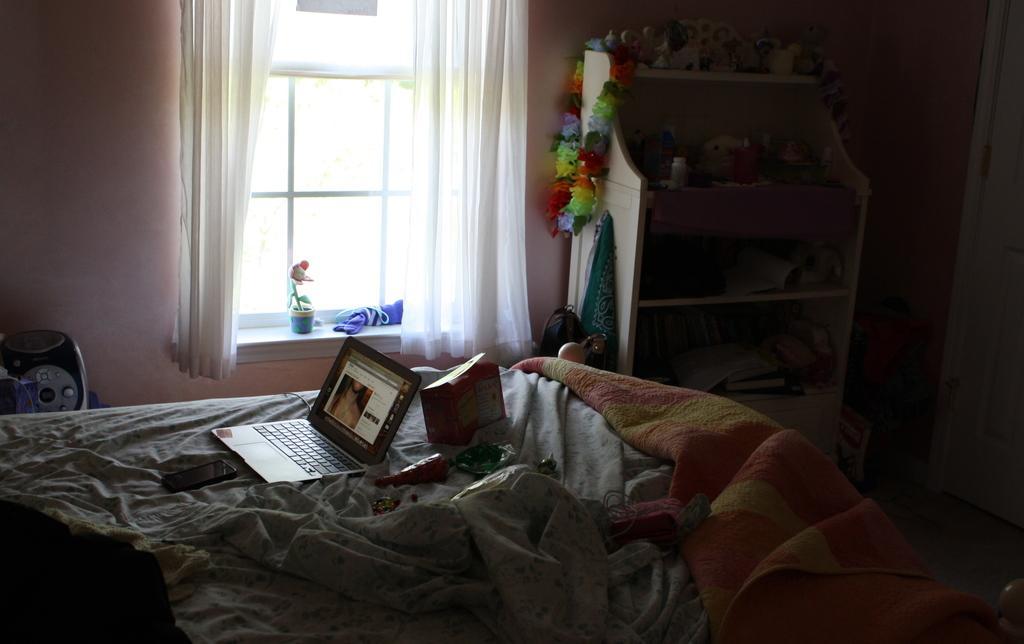In one or two sentences, can you explain what this image depicts? In this image there is an object and wall in the left corner. There is a bed, laptop, phone, blanket and other objects in the foreground. There is a wooden rack with objects on it in the right corner. There is a wall, curtains and window and small potted plant in the background. And there is a floor at the bottom. 